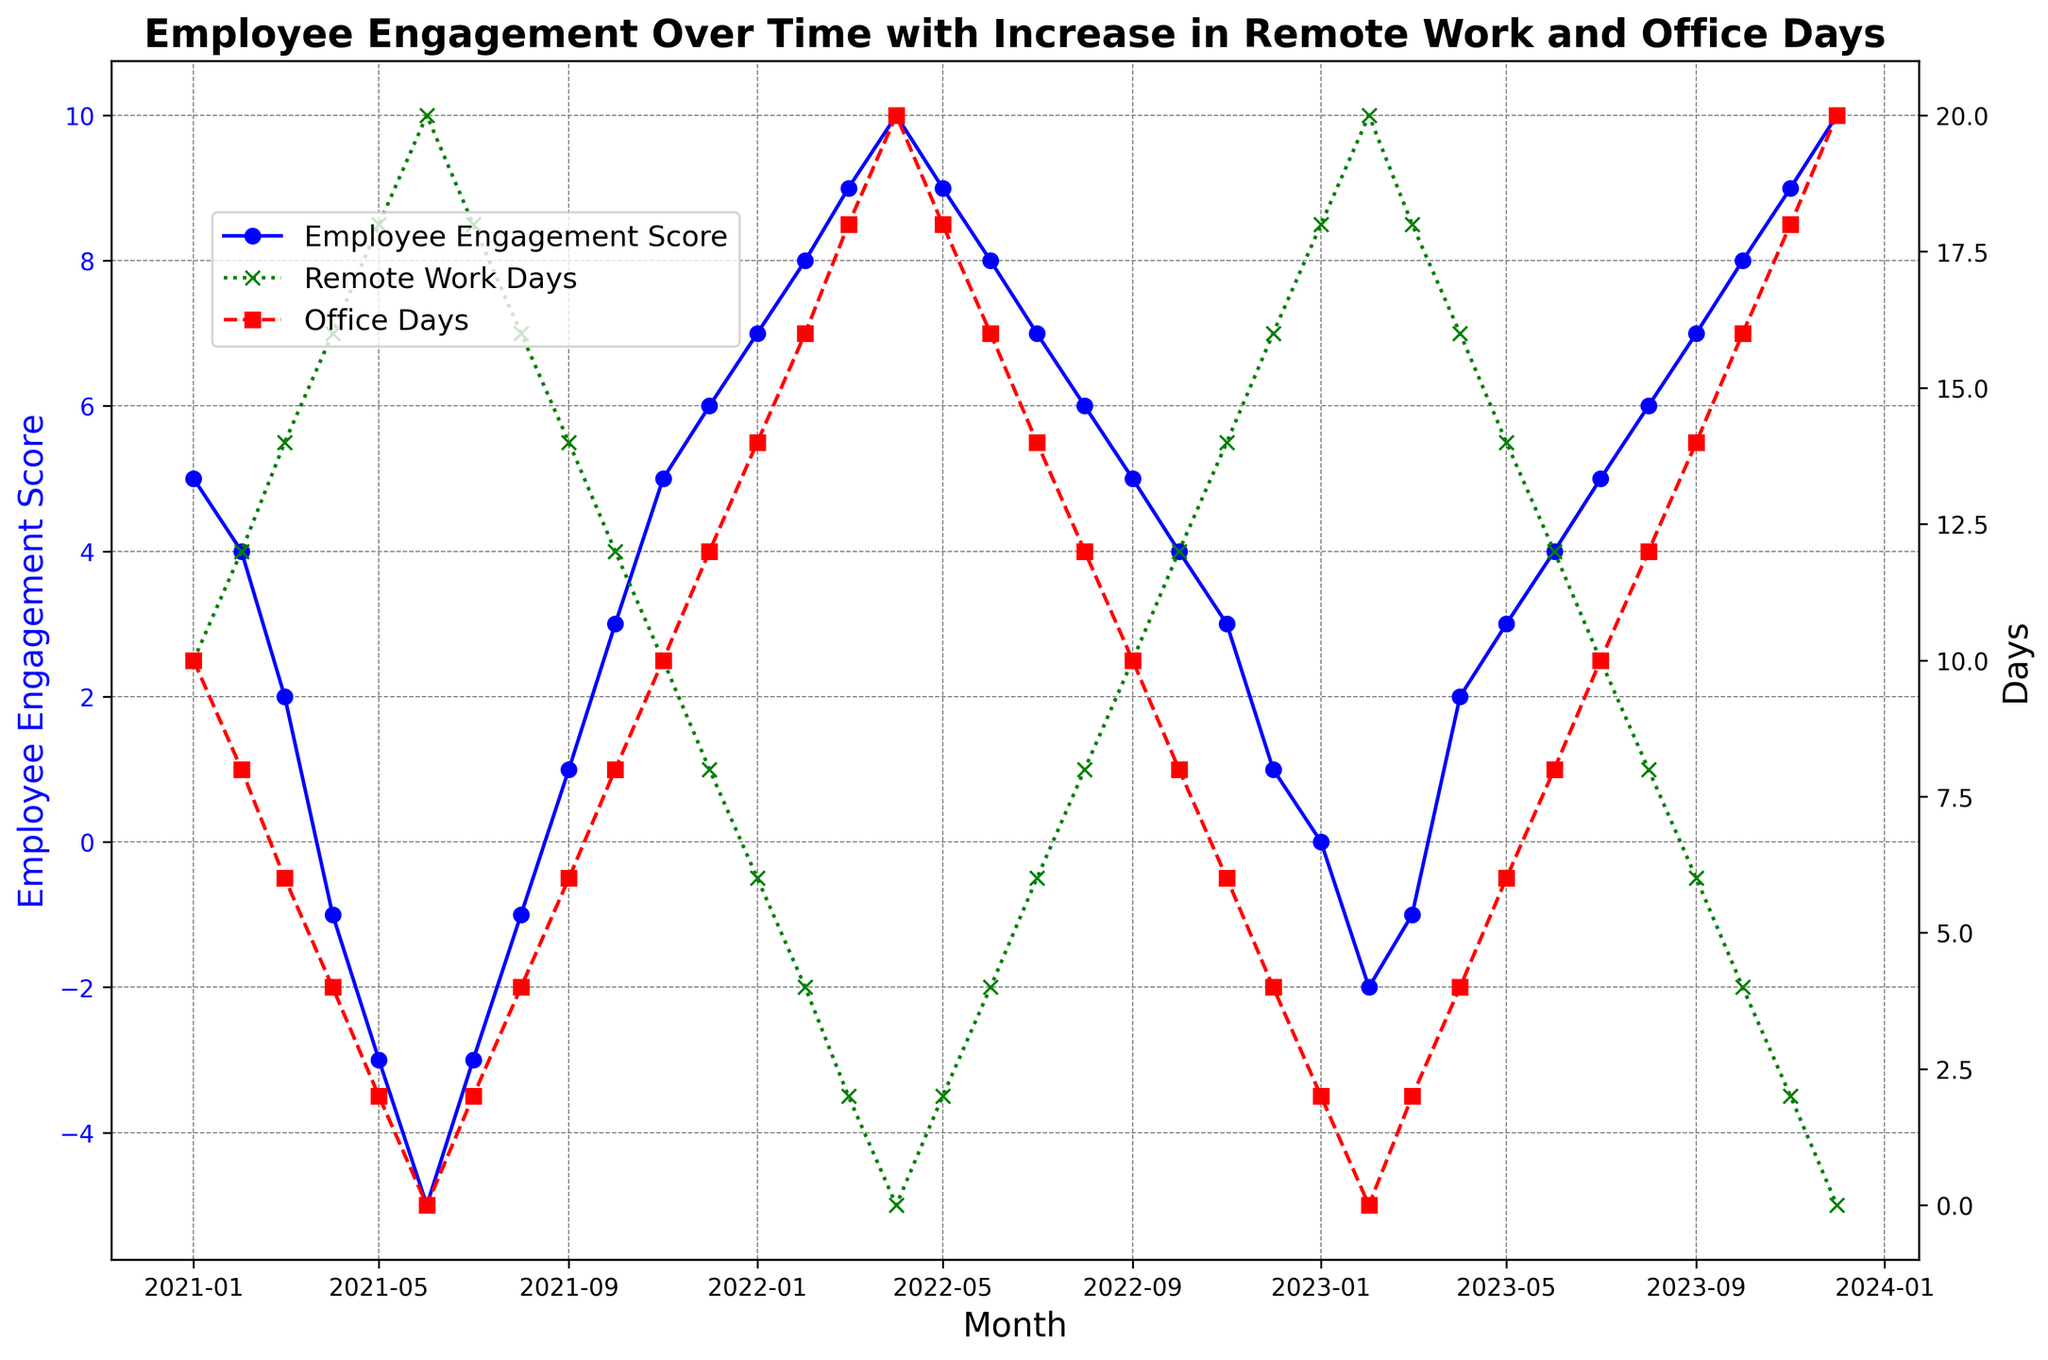What is the trend in Employee Engagement Score from Jan-21 to Dec-21? The Employee Engagement Score starts at 5 in Jan-21 and drops to -5 by Jun-21. Then it steadily climbs back up to 6 by Dec-21. This shows a U-shaped trend over the year 2021.
Answer: U-shaped trend During which months did the Employee Engagement Score reach its lowest point, and what was the score? The lowest Employee Engagement Score was observed in Jun-21 and it was -5.
Answer: Jun-21, -5 How does the number of Remote Work Days correlate with the Employee Engagement Score in the first half of 2021? From Jan-21 to Jun-21, as the number of Remote Work Days increased, the Employee Engagement Score decreased. Specifically, Remote Work Days increased from 10 to 20, while the Employee Engagement Score dropped from 5 to -5.
Answer: Negative correlation Around which month in 2021 do you see a transition from negative to positive Employee Engagement Scores? The transition from negative to positive Employee Engagement Scores occurs around Sep-21, where the score goes from -1 in Aug-21 to 1 in Sep-21.
Answer: Sep-21 Compare the Employee Engagement Score trend in 2021 and 2023. In 2021, the Employee Engagement Score starts high, drops mid-year, and then rises again. In 2023, the score starts neutral, dips briefly, and then steadily increases towards the end of the year.
Answer: Fluctuating in 2021, steady rise in 2023 What is the relationship between Office Days and Employee Engagement Score from Jan-21 to Dec-21? As the number of Office Days decreased from 10 in Jan-21 to 0 in Jun-21, Employee Engagement Score also decreased from 5 to -5. When Office Days started to increase in the second half of the year, the Employee Engagement Score also increased and reached 6 by Dec-21. This suggests a positive correlation.
Answer: Positive correlation Which month in 2023 had the lowest Employee Engagement Score, and how many Remote Work Days were there? The lowest Employee Engagement Score in 2023 was in Feb-23 with a score of -2. There were 20 Remote Work Days in that month.
Answer: Feb-23, 20 days What was the average Employee Engagement Score in the second half of 2022? The Employee Engagement Scores from Jul-22 to Dec-22 were 7, 6, 5, 4, 3, and 1 respectively. The average is calculated as (7 + 6 + 5 + 4 + 3 + 1) / 6 = 26 / 6 = 4.33
Answer: 4.33 How do the trends of Remote Work Days and Office Days differ over the period shown in the figure? Remote Work Days generally decrease over time while Office Days increase. Starting with 10 Remote Work Days in Jan-21, decreasing to 0 by Apr-22, and then fluctuating. Conversely, Office Days start at 10 in Jan-21, reaching 20 by Apr-22, and fluctuating afterward.
Answer: Inversely correlated trends 